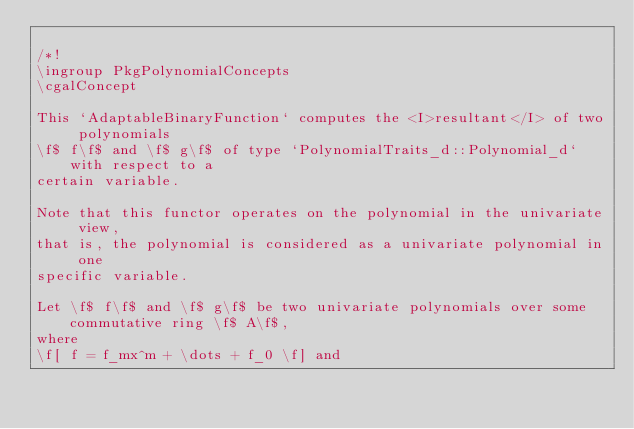<code> <loc_0><loc_0><loc_500><loc_500><_C_>
/*!
\ingroup PkgPolynomialConcepts
\cgalConcept

This `AdaptableBinaryFunction` computes the <I>resultant</I> of two polynomials 
\f$ f\f$ and \f$ g\f$ of type `PolynomialTraits_d::Polynomial_d` with respect to a 
certain variable. 

Note that this functor operates on the polynomial in the univariate view, 
that is, the polynomial is considered as a univariate polynomial in one 
specific variable. 

Let \f$ f\f$ and \f$ g\f$ be two univariate polynomials over some commutative ring \f$ A\f$, 
where 
\f[ f = f_mx^m + \dots + f_0 \f] and </code> 